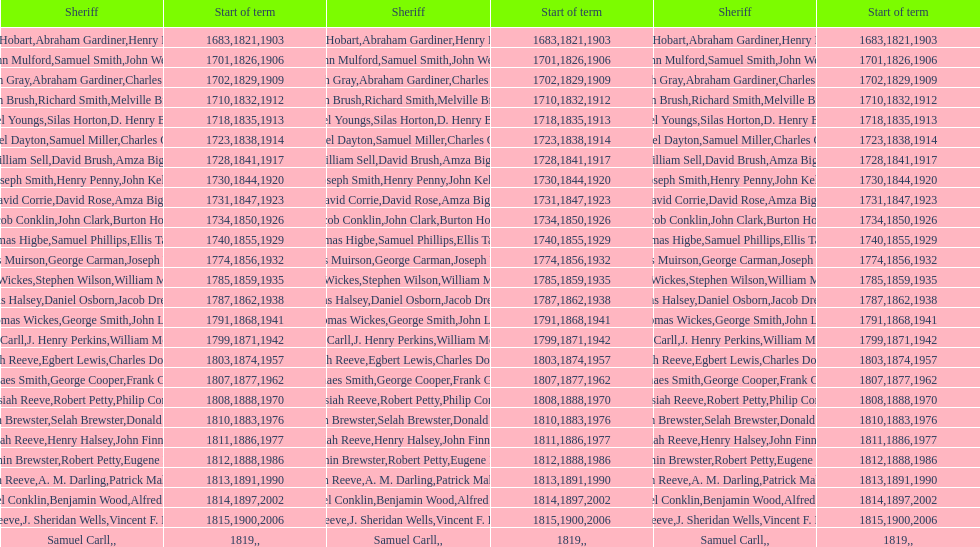During what period did benjamin brewster serve his second term? 1812. 